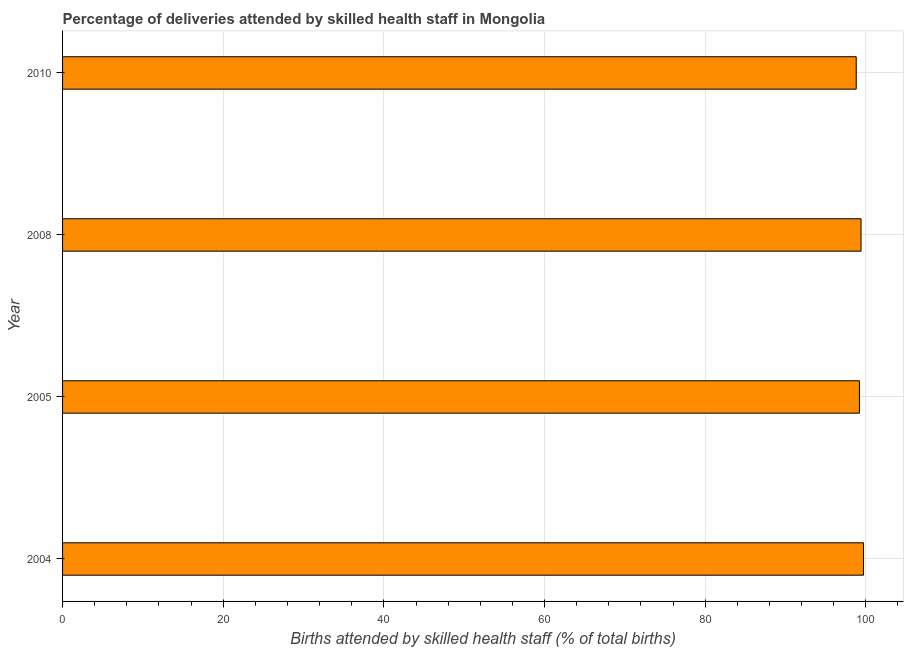Does the graph contain any zero values?
Provide a short and direct response. No. Does the graph contain grids?
Ensure brevity in your answer.  Yes. What is the title of the graph?
Your answer should be very brief. Percentage of deliveries attended by skilled health staff in Mongolia. What is the label or title of the X-axis?
Offer a terse response. Births attended by skilled health staff (% of total births). What is the label or title of the Y-axis?
Provide a short and direct response. Year. What is the number of births attended by skilled health staff in 2008?
Provide a short and direct response. 99.4. Across all years, what is the maximum number of births attended by skilled health staff?
Your response must be concise. 99.7. Across all years, what is the minimum number of births attended by skilled health staff?
Provide a short and direct response. 98.8. In which year was the number of births attended by skilled health staff maximum?
Provide a succinct answer. 2004. What is the sum of the number of births attended by skilled health staff?
Offer a terse response. 397.1. What is the average number of births attended by skilled health staff per year?
Provide a short and direct response. 99.28. What is the median number of births attended by skilled health staff?
Your answer should be very brief. 99.3. In how many years, is the number of births attended by skilled health staff greater than 84 %?
Offer a terse response. 4. What is the ratio of the number of births attended by skilled health staff in 2005 to that in 2010?
Offer a terse response. 1. Is the number of births attended by skilled health staff in 2004 less than that in 2008?
Give a very brief answer. No. Is the difference between the number of births attended by skilled health staff in 2004 and 2008 greater than the difference between any two years?
Offer a terse response. No. What is the difference between the highest and the second highest number of births attended by skilled health staff?
Offer a very short reply. 0.3. Is the sum of the number of births attended by skilled health staff in 2005 and 2010 greater than the maximum number of births attended by skilled health staff across all years?
Provide a short and direct response. Yes. What is the difference between the highest and the lowest number of births attended by skilled health staff?
Keep it short and to the point. 0.9. In how many years, is the number of births attended by skilled health staff greater than the average number of births attended by skilled health staff taken over all years?
Provide a succinct answer. 2. Are all the bars in the graph horizontal?
Make the answer very short. Yes. Are the values on the major ticks of X-axis written in scientific E-notation?
Offer a terse response. No. What is the Births attended by skilled health staff (% of total births) of 2004?
Ensure brevity in your answer.  99.7. What is the Births attended by skilled health staff (% of total births) of 2005?
Offer a terse response. 99.2. What is the Births attended by skilled health staff (% of total births) in 2008?
Give a very brief answer. 99.4. What is the Births attended by skilled health staff (% of total births) of 2010?
Keep it short and to the point. 98.8. What is the difference between the Births attended by skilled health staff (% of total births) in 2004 and 2008?
Offer a very short reply. 0.3. What is the difference between the Births attended by skilled health staff (% of total births) in 2004 and 2010?
Your answer should be compact. 0.9. What is the difference between the Births attended by skilled health staff (% of total births) in 2005 and 2008?
Keep it short and to the point. -0.2. What is the ratio of the Births attended by skilled health staff (% of total births) in 2004 to that in 2005?
Your answer should be compact. 1. What is the ratio of the Births attended by skilled health staff (% of total births) in 2004 to that in 2008?
Provide a succinct answer. 1. What is the ratio of the Births attended by skilled health staff (% of total births) in 2005 to that in 2010?
Ensure brevity in your answer.  1. What is the ratio of the Births attended by skilled health staff (% of total births) in 2008 to that in 2010?
Your answer should be very brief. 1.01. 